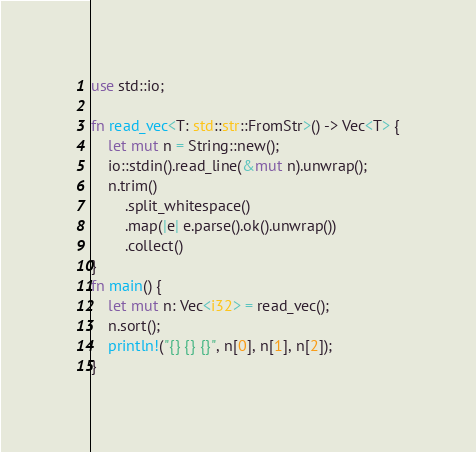<code> <loc_0><loc_0><loc_500><loc_500><_Rust_>use std::io;

fn read_vec<T: std::str::FromStr>() -> Vec<T> {
    let mut n = String::new();
    io::stdin().read_line(&mut n).unwrap();
    n.trim()
        .split_whitespace()
        .map(|e| e.parse().ok().unwrap())
        .collect()
}
fn main() {
    let mut n: Vec<i32> = read_vec();
    n.sort();
    println!("{} {} {}", n[0], n[1], n[2]);
}

</code> 